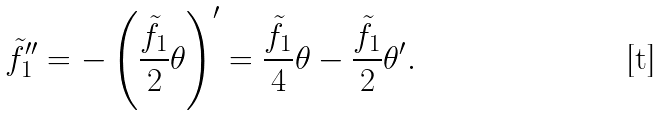Convert formula to latex. <formula><loc_0><loc_0><loc_500><loc_500>{ \tilde { f } _ { 1 } } ^ { \prime \prime } = - \left ( \frac { \tilde { f } _ { 1 } } { 2 } \theta \right ) ^ { \prime } = \frac { \tilde { f } _ { 1 } } { 4 } \theta - \frac { \tilde { f } _ { 1 } } { 2 } \theta ^ { \prime } .</formula> 